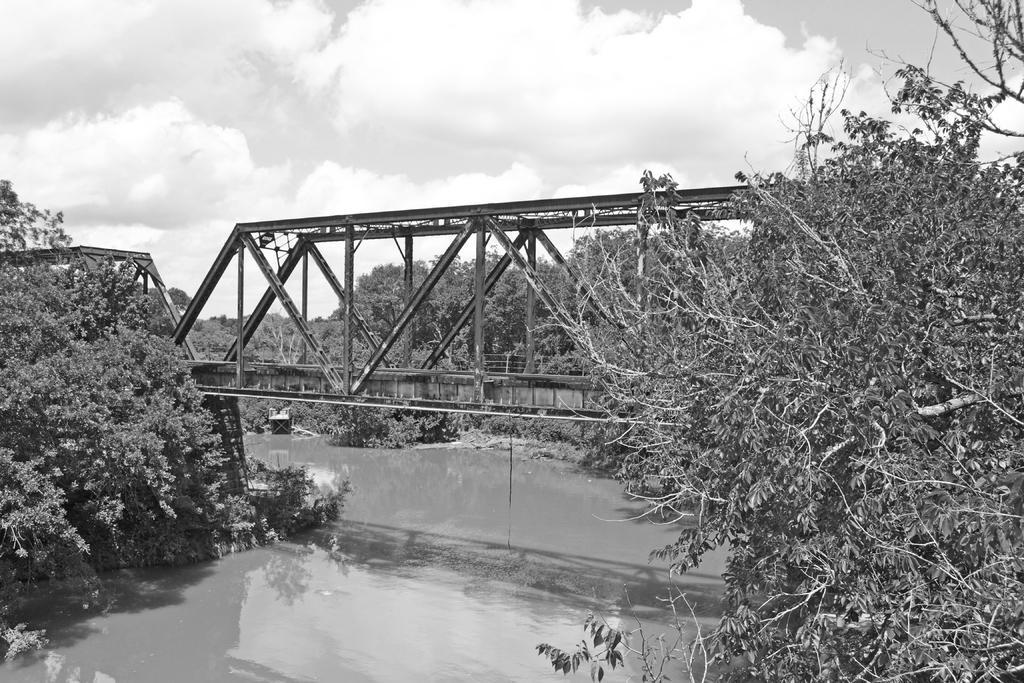In one or two sentences, can you explain what this image depicts? In this image, we can see some trees. There is a bridge in the middle of the image. There is a canal at the bottom of the image. There are clouds in the sky. 